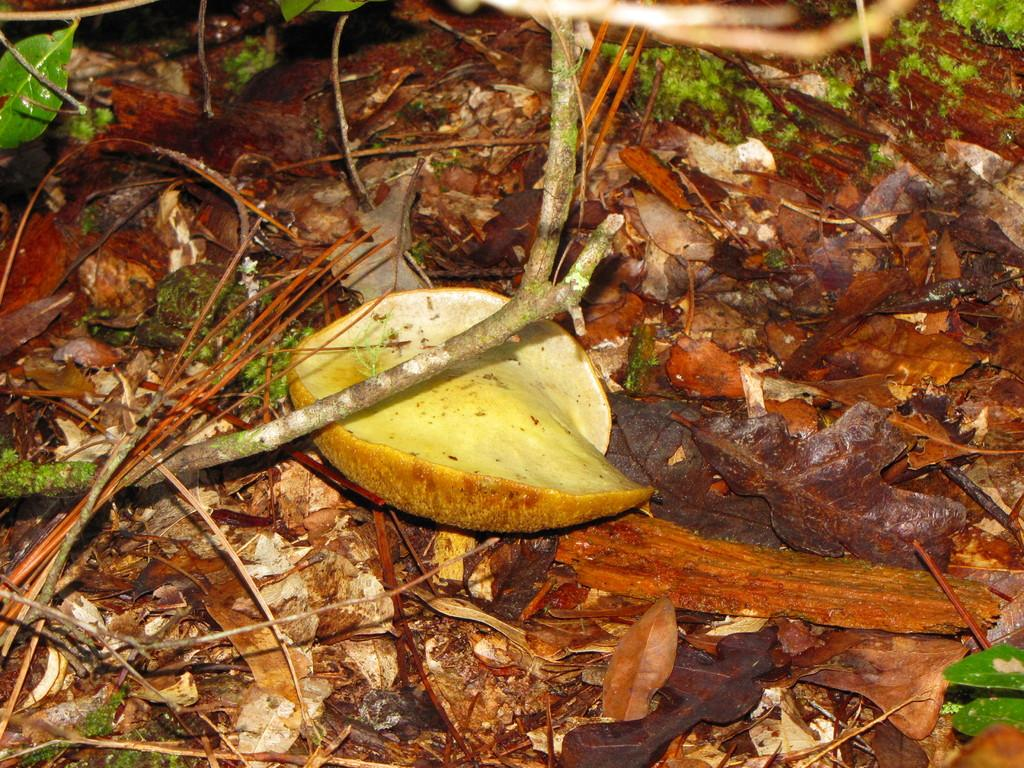What is present in the foreground of the image? There are dry leaves and sticks in the foreground of the image. Is there any indication of a fruit in the foreground of the image? There may be a fruit piece visible in the foreground of the image. What beginner's action is taking place in space in the image? There is no beginner's action taking place in space in the image, as it only features dry leaves, sticks, and possibly a fruit piece in the foreground. 